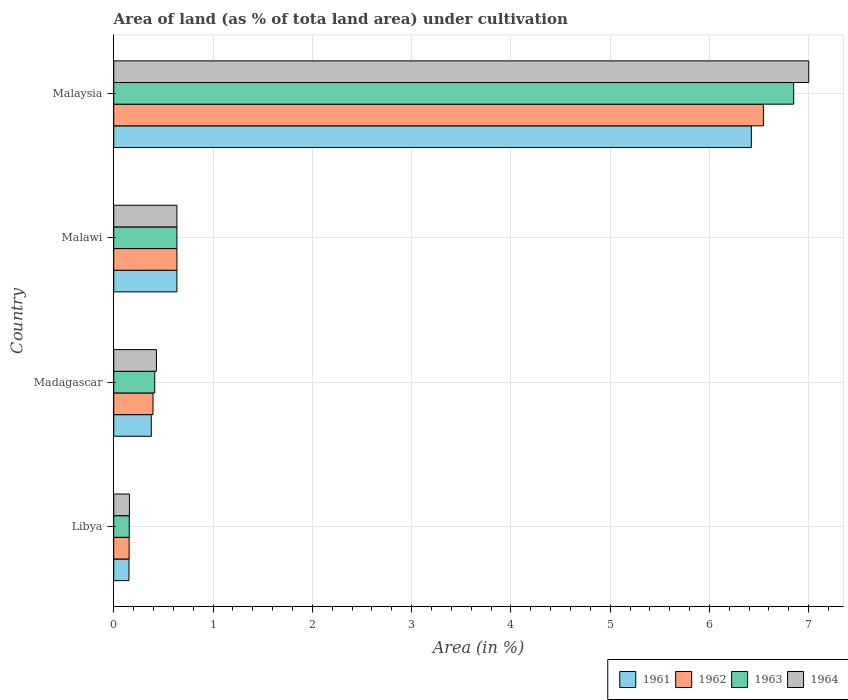How many different coloured bars are there?
Make the answer very short. 4. How many groups of bars are there?
Offer a very short reply. 4. Are the number of bars per tick equal to the number of legend labels?
Offer a very short reply. Yes. How many bars are there on the 2nd tick from the top?
Provide a short and direct response. 4. How many bars are there on the 3rd tick from the bottom?
Offer a terse response. 4. What is the label of the 2nd group of bars from the top?
Your answer should be compact. Malawi. What is the percentage of land under cultivation in 1962 in Malawi?
Offer a very short reply. 0.64. Across all countries, what is the maximum percentage of land under cultivation in 1964?
Your response must be concise. 7. Across all countries, what is the minimum percentage of land under cultivation in 1964?
Make the answer very short. 0.16. In which country was the percentage of land under cultivation in 1962 maximum?
Your response must be concise. Malaysia. In which country was the percentage of land under cultivation in 1962 minimum?
Give a very brief answer. Libya. What is the total percentage of land under cultivation in 1964 in the graph?
Provide a short and direct response. 8.22. What is the difference between the percentage of land under cultivation in 1961 in Libya and that in Malawi?
Offer a terse response. -0.48. What is the difference between the percentage of land under cultivation in 1964 in Malaysia and the percentage of land under cultivation in 1963 in Madagascar?
Keep it short and to the point. 6.59. What is the average percentage of land under cultivation in 1964 per country?
Make the answer very short. 2.06. What is the difference between the percentage of land under cultivation in 1961 and percentage of land under cultivation in 1964 in Malaysia?
Your answer should be very brief. -0.58. In how many countries, is the percentage of land under cultivation in 1964 greater than 2.4 %?
Ensure brevity in your answer.  1. What is the ratio of the percentage of land under cultivation in 1961 in Malawi to that in Malaysia?
Offer a terse response. 0.1. Is the percentage of land under cultivation in 1964 in Madagascar less than that in Malawi?
Ensure brevity in your answer.  Yes. Is the difference between the percentage of land under cultivation in 1961 in Malawi and Malaysia greater than the difference between the percentage of land under cultivation in 1964 in Malawi and Malaysia?
Provide a short and direct response. Yes. What is the difference between the highest and the second highest percentage of land under cultivation in 1962?
Give a very brief answer. 5.91. What is the difference between the highest and the lowest percentage of land under cultivation in 1963?
Your response must be concise. 6.69. In how many countries, is the percentage of land under cultivation in 1961 greater than the average percentage of land under cultivation in 1961 taken over all countries?
Provide a succinct answer. 1. What does the 1st bar from the top in Malaysia represents?
Your answer should be very brief. 1964. Are all the bars in the graph horizontal?
Keep it short and to the point. Yes. What is the difference between two consecutive major ticks on the X-axis?
Make the answer very short. 1. Where does the legend appear in the graph?
Your response must be concise. Bottom right. How many legend labels are there?
Your answer should be very brief. 4. What is the title of the graph?
Your response must be concise. Area of land (as % of tota land area) under cultivation. Does "2014" appear as one of the legend labels in the graph?
Your response must be concise. No. What is the label or title of the X-axis?
Your answer should be compact. Area (in %). What is the label or title of the Y-axis?
Make the answer very short. Country. What is the Area (in %) of 1961 in Libya?
Offer a terse response. 0.15. What is the Area (in %) in 1962 in Libya?
Offer a terse response. 0.16. What is the Area (in %) of 1963 in Libya?
Give a very brief answer. 0.16. What is the Area (in %) in 1964 in Libya?
Make the answer very short. 0.16. What is the Area (in %) in 1961 in Madagascar?
Offer a very short reply. 0.38. What is the Area (in %) in 1962 in Madagascar?
Offer a very short reply. 0.4. What is the Area (in %) of 1963 in Madagascar?
Your answer should be compact. 0.41. What is the Area (in %) in 1964 in Madagascar?
Offer a terse response. 0.43. What is the Area (in %) of 1961 in Malawi?
Give a very brief answer. 0.64. What is the Area (in %) of 1962 in Malawi?
Your answer should be very brief. 0.64. What is the Area (in %) in 1963 in Malawi?
Provide a short and direct response. 0.64. What is the Area (in %) of 1964 in Malawi?
Ensure brevity in your answer.  0.64. What is the Area (in %) in 1961 in Malaysia?
Ensure brevity in your answer.  6.42. What is the Area (in %) in 1962 in Malaysia?
Your response must be concise. 6.54. What is the Area (in %) of 1963 in Malaysia?
Offer a terse response. 6.85. What is the Area (in %) in 1964 in Malaysia?
Keep it short and to the point. 7. Across all countries, what is the maximum Area (in %) of 1961?
Offer a terse response. 6.42. Across all countries, what is the maximum Area (in %) in 1962?
Give a very brief answer. 6.54. Across all countries, what is the maximum Area (in %) of 1963?
Your answer should be very brief. 6.85. Across all countries, what is the maximum Area (in %) in 1964?
Give a very brief answer. 7. Across all countries, what is the minimum Area (in %) of 1961?
Provide a short and direct response. 0.15. Across all countries, what is the minimum Area (in %) in 1962?
Offer a very short reply. 0.16. Across all countries, what is the minimum Area (in %) of 1963?
Provide a succinct answer. 0.16. Across all countries, what is the minimum Area (in %) in 1964?
Your answer should be compact. 0.16. What is the total Area (in %) in 1961 in the graph?
Make the answer very short. 7.59. What is the total Area (in %) of 1962 in the graph?
Make the answer very short. 7.73. What is the total Area (in %) in 1963 in the graph?
Keep it short and to the point. 8.05. What is the total Area (in %) in 1964 in the graph?
Make the answer very short. 8.22. What is the difference between the Area (in %) in 1961 in Libya and that in Madagascar?
Make the answer very short. -0.22. What is the difference between the Area (in %) of 1962 in Libya and that in Madagascar?
Give a very brief answer. -0.24. What is the difference between the Area (in %) in 1963 in Libya and that in Madagascar?
Make the answer very short. -0.26. What is the difference between the Area (in %) in 1964 in Libya and that in Madagascar?
Make the answer very short. -0.27. What is the difference between the Area (in %) of 1961 in Libya and that in Malawi?
Your answer should be very brief. -0.48. What is the difference between the Area (in %) of 1962 in Libya and that in Malawi?
Ensure brevity in your answer.  -0.48. What is the difference between the Area (in %) of 1963 in Libya and that in Malawi?
Make the answer very short. -0.48. What is the difference between the Area (in %) in 1964 in Libya and that in Malawi?
Offer a very short reply. -0.48. What is the difference between the Area (in %) of 1961 in Libya and that in Malaysia?
Your answer should be very brief. -6.27. What is the difference between the Area (in %) in 1962 in Libya and that in Malaysia?
Provide a succinct answer. -6.39. What is the difference between the Area (in %) in 1963 in Libya and that in Malaysia?
Your answer should be very brief. -6.69. What is the difference between the Area (in %) of 1964 in Libya and that in Malaysia?
Provide a short and direct response. -6.84. What is the difference between the Area (in %) in 1961 in Madagascar and that in Malawi?
Offer a terse response. -0.26. What is the difference between the Area (in %) of 1962 in Madagascar and that in Malawi?
Keep it short and to the point. -0.24. What is the difference between the Area (in %) of 1963 in Madagascar and that in Malawi?
Your response must be concise. -0.22. What is the difference between the Area (in %) of 1964 in Madagascar and that in Malawi?
Offer a terse response. -0.21. What is the difference between the Area (in %) of 1961 in Madagascar and that in Malaysia?
Make the answer very short. -6.04. What is the difference between the Area (in %) of 1962 in Madagascar and that in Malaysia?
Keep it short and to the point. -6.15. What is the difference between the Area (in %) of 1963 in Madagascar and that in Malaysia?
Your response must be concise. -6.44. What is the difference between the Area (in %) in 1964 in Madagascar and that in Malaysia?
Your answer should be compact. -6.57. What is the difference between the Area (in %) in 1961 in Malawi and that in Malaysia?
Offer a very short reply. -5.79. What is the difference between the Area (in %) in 1962 in Malawi and that in Malaysia?
Your response must be concise. -5.91. What is the difference between the Area (in %) of 1963 in Malawi and that in Malaysia?
Your answer should be very brief. -6.21. What is the difference between the Area (in %) of 1964 in Malawi and that in Malaysia?
Keep it short and to the point. -6.36. What is the difference between the Area (in %) in 1961 in Libya and the Area (in %) in 1962 in Madagascar?
Keep it short and to the point. -0.24. What is the difference between the Area (in %) in 1961 in Libya and the Area (in %) in 1963 in Madagascar?
Provide a succinct answer. -0.26. What is the difference between the Area (in %) of 1961 in Libya and the Area (in %) of 1964 in Madagascar?
Provide a short and direct response. -0.28. What is the difference between the Area (in %) in 1962 in Libya and the Area (in %) in 1963 in Madagascar?
Offer a terse response. -0.26. What is the difference between the Area (in %) in 1962 in Libya and the Area (in %) in 1964 in Madagascar?
Your answer should be compact. -0.27. What is the difference between the Area (in %) of 1963 in Libya and the Area (in %) of 1964 in Madagascar?
Your answer should be compact. -0.27. What is the difference between the Area (in %) of 1961 in Libya and the Area (in %) of 1962 in Malawi?
Provide a short and direct response. -0.48. What is the difference between the Area (in %) of 1961 in Libya and the Area (in %) of 1963 in Malawi?
Give a very brief answer. -0.48. What is the difference between the Area (in %) in 1961 in Libya and the Area (in %) in 1964 in Malawi?
Provide a succinct answer. -0.48. What is the difference between the Area (in %) in 1962 in Libya and the Area (in %) in 1963 in Malawi?
Give a very brief answer. -0.48. What is the difference between the Area (in %) in 1962 in Libya and the Area (in %) in 1964 in Malawi?
Your answer should be very brief. -0.48. What is the difference between the Area (in %) of 1963 in Libya and the Area (in %) of 1964 in Malawi?
Your answer should be very brief. -0.48. What is the difference between the Area (in %) in 1961 in Libya and the Area (in %) in 1962 in Malaysia?
Provide a succinct answer. -6.39. What is the difference between the Area (in %) in 1961 in Libya and the Area (in %) in 1963 in Malaysia?
Your answer should be very brief. -6.69. What is the difference between the Area (in %) of 1961 in Libya and the Area (in %) of 1964 in Malaysia?
Ensure brevity in your answer.  -6.85. What is the difference between the Area (in %) in 1962 in Libya and the Area (in %) in 1963 in Malaysia?
Keep it short and to the point. -6.69. What is the difference between the Area (in %) in 1962 in Libya and the Area (in %) in 1964 in Malaysia?
Offer a terse response. -6.85. What is the difference between the Area (in %) of 1963 in Libya and the Area (in %) of 1964 in Malaysia?
Offer a very short reply. -6.84. What is the difference between the Area (in %) of 1961 in Madagascar and the Area (in %) of 1962 in Malawi?
Provide a short and direct response. -0.26. What is the difference between the Area (in %) of 1961 in Madagascar and the Area (in %) of 1963 in Malawi?
Your answer should be very brief. -0.26. What is the difference between the Area (in %) of 1961 in Madagascar and the Area (in %) of 1964 in Malawi?
Your response must be concise. -0.26. What is the difference between the Area (in %) of 1962 in Madagascar and the Area (in %) of 1963 in Malawi?
Your answer should be very brief. -0.24. What is the difference between the Area (in %) of 1962 in Madagascar and the Area (in %) of 1964 in Malawi?
Offer a very short reply. -0.24. What is the difference between the Area (in %) of 1963 in Madagascar and the Area (in %) of 1964 in Malawi?
Make the answer very short. -0.22. What is the difference between the Area (in %) of 1961 in Madagascar and the Area (in %) of 1962 in Malaysia?
Provide a short and direct response. -6.17. What is the difference between the Area (in %) of 1961 in Madagascar and the Area (in %) of 1963 in Malaysia?
Give a very brief answer. -6.47. What is the difference between the Area (in %) in 1961 in Madagascar and the Area (in %) in 1964 in Malaysia?
Offer a very short reply. -6.62. What is the difference between the Area (in %) of 1962 in Madagascar and the Area (in %) of 1963 in Malaysia?
Make the answer very short. -6.45. What is the difference between the Area (in %) of 1962 in Madagascar and the Area (in %) of 1964 in Malaysia?
Your answer should be very brief. -6.61. What is the difference between the Area (in %) of 1963 in Madagascar and the Area (in %) of 1964 in Malaysia?
Your response must be concise. -6.59. What is the difference between the Area (in %) in 1961 in Malawi and the Area (in %) in 1962 in Malaysia?
Keep it short and to the point. -5.91. What is the difference between the Area (in %) of 1961 in Malawi and the Area (in %) of 1963 in Malaysia?
Offer a very short reply. -6.21. What is the difference between the Area (in %) in 1961 in Malawi and the Area (in %) in 1964 in Malaysia?
Keep it short and to the point. -6.36. What is the difference between the Area (in %) in 1962 in Malawi and the Area (in %) in 1963 in Malaysia?
Your answer should be compact. -6.21. What is the difference between the Area (in %) of 1962 in Malawi and the Area (in %) of 1964 in Malaysia?
Provide a succinct answer. -6.36. What is the difference between the Area (in %) in 1963 in Malawi and the Area (in %) in 1964 in Malaysia?
Your response must be concise. -6.36. What is the average Area (in %) in 1961 per country?
Your answer should be very brief. 1.9. What is the average Area (in %) of 1962 per country?
Your answer should be compact. 1.93. What is the average Area (in %) in 1963 per country?
Keep it short and to the point. 2.01. What is the average Area (in %) of 1964 per country?
Your answer should be very brief. 2.06. What is the difference between the Area (in %) of 1961 and Area (in %) of 1962 in Libya?
Give a very brief answer. -0. What is the difference between the Area (in %) of 1961 and Area (in %) of 1963 in Libya?
Provide a succinct answer. -0. What is the difference between the Area (in %) in 1961 and Area (in %) in 1964 in Libya?
Provide a short and direct response. -0. What is the difference between the Area (in %) of 1962 and Area (in %) of 1963 in Libya?
Provide a succinct answer. -0. What is the difference between the Area (in %) of 1962 and Area (in %) of 1964 in Libya?
Your answer should be very brief. -0. What is the difference between the Area (in %) of 1963 and Area (in %) of 1964 in Libya?
Offer a very short reply. -0. What is the difference between the Area (in %) of 1961 and Area (in %) of 1962 in Madagascar?
Offer a very short reply. -0.02. What is the difference between the Area (in %) in 1961 and Area (in %) in 1963 in Madagascar?
Your answer should be compact. -0.03. What is the difference between the Area (in %) of 1961 and Area (in %) of 1964 in Madagascar?
Your answer should be very brief. -0.05. What is the difference between the Area (in %) in 1962 and Area (in %) in 1963 in Madagascar?
Offer a terse response. -0.02. What is the difference between the Area (in %) of 1962 and Area (in %) of 1964 in Madagascar?
Give a very brief answer. -0.03. What is the difference between the Area (in %) in 1963 and Area (in %) in 1964 in Madagascar?
Give a very brief answer. -0.02. What is the difference between the Area (in %) of 1961 and Area (in %) of 1964 in Malawi?
Provide a short and direct response. 0. What is the difference between the Area (in %) in 1962 and Area (in %) in 1963 in Malawi?
Offer a very short reply. 0. What is the difference between the Area (in %) in 1962 and Area (in %) in 1964 in Malawi?
Ensure brevity in your answer.  0. What is the difference between the Area (in %) in 1961 and Area (in %) in 1962 in Malaysia?
Provide a succinct answer. -0.12. What is the difference between the Area (in %) in 1961 and Area (in %) in 1963 in Malaysia?
Provide a short and direct response. -0.43. What is the difference between the Area (in %) in 1961 and Area (in %) in 1964 in Malaysia?
Your answer should be very brief. -0.58. What is the difference between the Area (in %) of 1962 and Area (in %) of 1963 in Malaysia?
Ensure brevity in your answer.  -0.3. What is the difference between the Area (in %) in 1962 and Area (in %) in 1964 in Malaysia?
Offer a terse response. -0.46. What is the difference between the Area (in %) of 1963 and Area (in %) of 1964 in Malaysia?
Provide a succinct answer. -0.15. What is the ratio of the Area (in %) of 1961 in Libya to that in Madagascar?
Provide a succinct answer. 0.41. What is the ratio of the Area (in %) in 1962 in Libya to that in Madagascar?
Your answer should be compact. 0.39. What is the ratio of the Area (in %) in 1963 in Libya to that in Madagascar?
Offer a terse response. 0.38. What is the ratio of the Area (in %) in 1964 in Libya to that in Madagascar?
Give a very brief answer. 0.37. What is the ratio of the Area (in %) in 1961 in Libya to that in Malawi?
Provide a succinct answer. 0.24. What is the ratio of the Area (in %) of 1962 in Libya to that in Malawi?
Provide a succinct answer. 0.24. What is the ratio of the Area (in %) of 1963 in Libya to that in Malawi?
Offer a very short reply. 0.25. What is the ratio of the Area (in %) of 1964 in Libya to that in Malawi?
Your answer should be very brief. 0.25. What is the ratio of the Area (in %) in 1961 in Libya to that in Malaysia?
Make the answer very short. 0.02. What is the ratio of the Area (in %) of 1962 in Libya to that in Malaysia?
Provide a short and direct response. 0.02. What is the ratio of the Area (in %) in 1963 in Libya to that in Malaysia?
Give a very brief answer. 0.02. What is the ratio of the Area (in %) of 1964 in Libya to that in Malaysia?
Offer a terse response. 0.02. What is the ratio of the Area (in %) of 1961 in Madagascar to that in Malawi?
Make the answer very short. 0.59. What is the ratio of the Area (in %) in 1962 in Madagascar to that in Malawi?
Ensure brevity in your answer.  0.62. What is the ratio of the Area (in %) in 1963 in Madagascar to that in Malawi?
Offer a terse response. 0.65. What is the ratio of the Area (in %) of 1964 in Madagascar to that in Malawi?
Your response must be concise. 0.68. What is the ratio of the Area (in %) in 1961 in Madagascar to that in Malaysia?
Your answer should be compact. 0.06. What is the ratio of the Area (in %) of 1962 in Madagascar to that in Malaysia?
Your response must be concise. 0.06. What is the ratio of the Area (in %) of 1963 in Madagascar to that in Malaysia?
Provide a short and direct response. 0.06. What is the ratio of the Area (in %) in 1964 in Madagascar to that in Malaysia?
Offer a very short reply. 0.06. What is the ratio of the Area (in %) of 1961 in Malawi to that in Malaysia?
Make the answer very short. 0.1. What is the ratio of the Area (in %) in 1962 in Malawi to that in Malaysia?
Keep it short and to the point. 0.1. What is the ratio of the Area (in %) of 1963 in Malawi to that in Malaysia?
Keep it short and to the point. 0.09. What is the ratio of the Area (in %) of 1964 in Malawi to that in Malaysia?
Give a very brief answer. 0.09. What is the difference between the highest and the second highest Area (in %) of 1961?
Your answer should be very brief. 5.79. What is the difference between the highest and the second highest Area (in %) in 1962?
Your answer should be compact. 5.91. What is the difference between the highest and the second highest Area (in %) in 1963?
Keep it short and to the point. 6.21. What is the difference between the highest and the second highest Area (in %) of 1964?
Your answer should be compact. 6.36. What is the difference between the highest and the lowest Area (in %) in 1961?
Provide a succinct answer. 6.27. What is the difference between the highest and the lowest Area (in %) in 1962?
Your answer should be very brief. 6.39. What is the difference between the highest and the lowest Area (in %) of 1963?
Offer a very short reply. 6.69. What is the difference between the highest and the lowest Area (in %) in 1964?
Offer a very short reply. 6.84. 